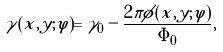Convert formula to latex. <formula><loc_0><loc_0><loc_500><loc_500>\gamma ( x , y ; \varphi ) = \gamma _ { 0 } - \frac { 2 \pi \phi ( x , y ; \varphi ) } { \Phi _ { 0 } } ,</formula> 